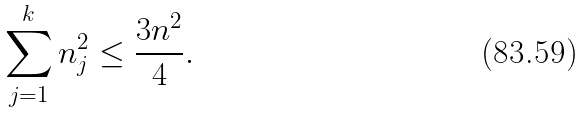Convert formula to latex. <formula><loc_0><loc_0><loc_500><loc_500>\sum _ { j = 1 } ^ { k } n _ { j } ^ { 2 } \leq \frac { 3 n ^ { 2 } } { 4 } .</formula> 